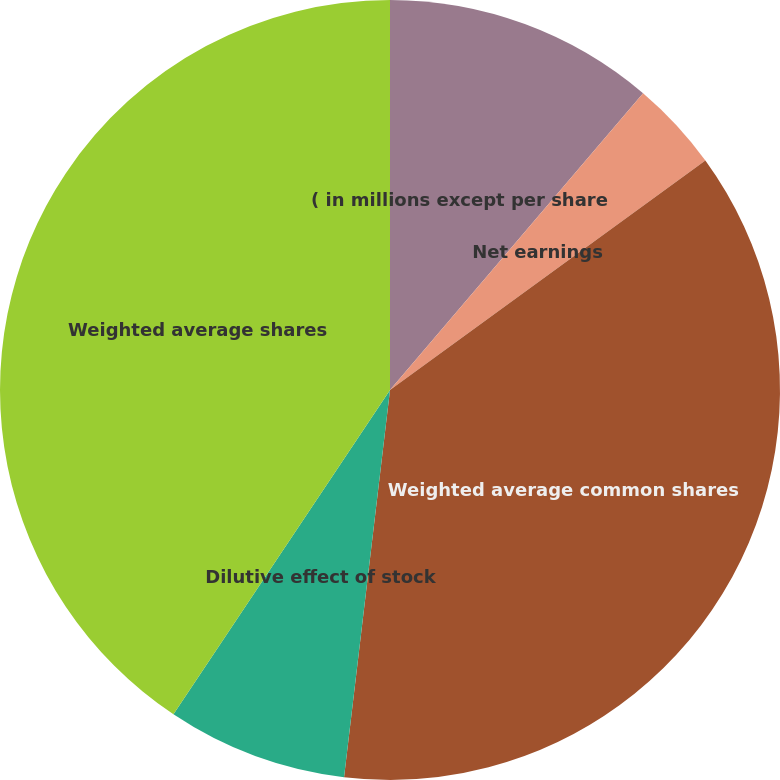Convert chart. <chart><loc_0><loc_0><loc_500><loc_500><pie_chart><fcel>( in millions except per share<fcel>Net earnings<fcel>Weighted average common shares<fcel>Dilutive effect of stock<fcel>Weighted average shares<fcel>Diluted earnings per share<nl><fcel>11.24%<fcel>3.75%<fcel>36.89%<fcel>7.49%<fcel>40.63%<fcel>0.0%<nl></chart> 